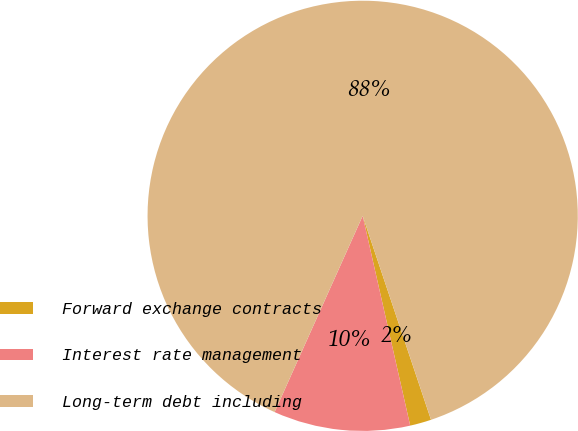Convert chart. <chart><loc_0><loc_0><loc_500><loc_500><pie_chart><fcel>Forward exchange contracts<fcel>Interest rate management<fcel>Long-term debt including<nl><fcel>1.6%<fcel>10.26%<fcel>88.14%<nl></chart> 